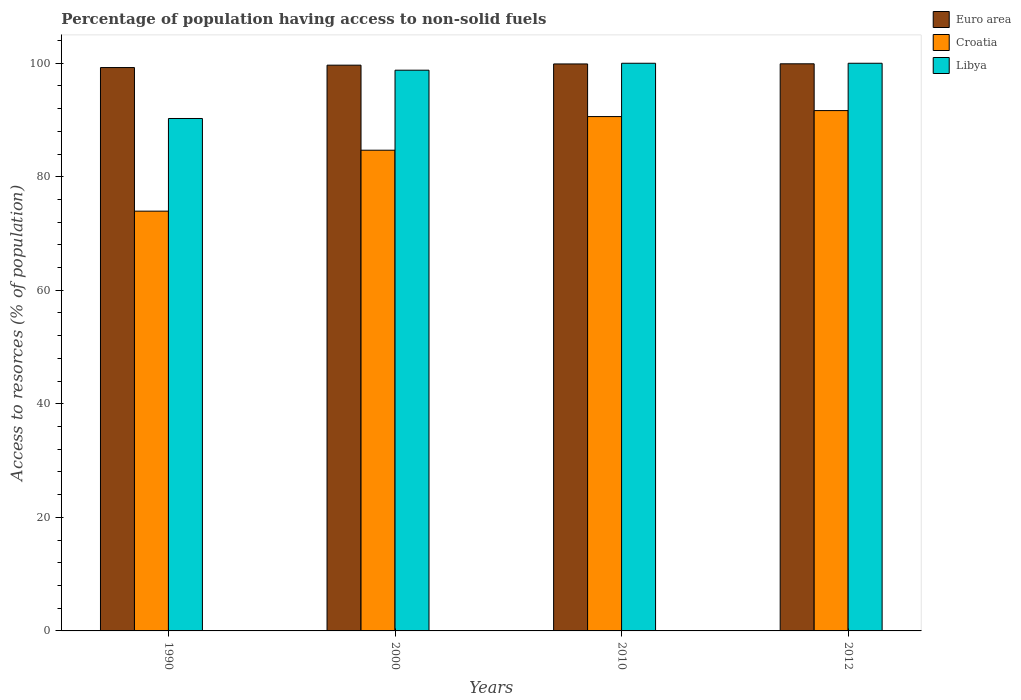How many different coloured bars are there?
Offer a terse response. 3. In how many cases, is the number of bars for a given year not equal to the number of legend labels?
Keep it short and to the point. 0. What is the percentage of population having access to non-solid fuels in Croatia in 2010?
Give a very brief answer. 90.6. Across all years, what is the maximum percentage of population having access to non-solid fuels in Libya?
Ensure brevity in your answer.  99.99. Across all years, what is the minimum percentage of population having access to non-solid fuels in Croatia?
Offer a very short reply. 73.94. In which year was the percentage of population having access to non-solid fuels in Libya maximum?
Ensure brevity in your answer.  2010. In which year was the percentage of population having access to non-solid fuels in Croatia minimum?
Keep it short and to the point. 1990. What is the total percentage of population having access to non-solid fuels in Libya in the graph?
Keep it short and to the point. 389.01. What is the difference between the percentage of population having access to non-solid fuels in Euro area in 2010 and that in 2012?
Make the answer very short. -0.02. What is the difference between the percentage of population having access to non-solid fuels in Croatia in 2000 and the percentage of population having access to non-solid fuels in Libya in 1990?
Ensure brevity in your answer.  -5.59. What is the average percentage of population having access to non-solid fuels in Libya per year?
Keep it short and to the point. 97.25. In the year 1990, what is the difference between the percentage of population having access to non-solid fuels in Libya and percentage of population having access to non-solid fuels in Euro area?
Give a very brief answer. -8.97. In how many years, is the percentage of population having access to non-solid fuels in Croatia greater than 88 %?
Give a very brief answer. 2. Is the percentage of population having access to non-solid fuels in Croatia in 1990 less than that in 2010?
Your answer should be compact. Yes. What is the difference between the highest and the second highest percentage of population having access to non-solid fuels in Croatia?
Your answer should be compact. 1.05. What is the difference between the highest and the lowest percentage of population having access to non-solid fuels in Libya?
Offer a very short reply. 9.73. In how many years, is the percentage of population having access to non-solid fuels in Libya greater than the average percentage of population having access to non-solid fuels in Libya taken over all years?
Ensure brevity in your answer.  3. Is the sum of the percentage of population having access to non-solid fuels in Euro area in 2000 and 2012 greater than the maximum percentage of population having access to non-solid fuels in Libya across all years?
Provide a succinct answer. Yes. What does the 3rd bar from the left in 1990 represents?
Offer a terse response. Libya. What does the 2nd bar from the right in 2000 represents?
Offer a terse response. Croatia. Is it the case that in every year, the sum of the percentage of population having access to non-solid fuels in Libya and percentage of population having access to non-solid fuels in Euro area is greater than the percentage of population having access to non-solid fuels in Croatia?
Provide a succinct answer. Yes. Are all the bars in the graph horizontal?
Your answer should be very brief. No. What is the difference between two consecutive major ticks on the Y-axis?
Offer a very short reply. 20. Are the values on the major ticks of Y-axis written in scientific E-notation?
Provide a short and direct response. No. Does the graph contain any zero values?
Provide a short and direct response. No. Where does the legend appear in the graph?
Offer a terse response. Top right. What is the title of the graph?
Keep it short and to the point. Percentage of population having access to non-solid fuels. Does "Marshall Islands" appear as one of the legend labels in the graph?
Your response must be concise. No. What is the label or title of the Y-axis?
Offer a very short reply. Access to resorces (% of population). What is the Access to resorces (% of population) in Euro area in 1990?
Make the answer very short. 99.23. What is the Access to resorces (% of population) in Croatia in 1990?
Offer a terse response. 73.94. What is the Access to resorces (% of population) in Libya in 1990?
Provide a succinct answer. 90.26. What is the Access to resorces (% of population) of Euro area in 2000?
Your answer should be very brief. 99.66. What is the Access to resorces (% of population) of Croatia in 2000?
Offer a very short reply. 84.67. What is the Access to resorces (% of population) of Libya in 2000?
Give a very brief answer. 98.77. What is the Access to resorces (% of population) of Euro area in 2010?
Give a very brief answer. 99.87. What is the Access to resorces (% of population) of Croatia in 2010?
Ensure brevity in your answer.  90.6. What is the Access to resorces (% of population) of Libya in 2010?
Give a very brief answer. 99.99. What is the Access to resorces (% of population) of Euro area in 2012?
Ensure brevity in your answer.  99.89. What is the Access to resorces (% of population) in Croatia in 2012?
Make the answer very short. 91.65. What is the Access to resorces (% of population) in Libya in 2012?
Make the answer very short. 99.99. Across all years, what is the maximum Access to resorces (% of population) in Euro area?
Provide a short and direct response. 99.89. Across all years, what is the maximum Access to resorces (% of population) in Croatia?
Keep it short and to the point. 91.65. Across all years, what is the maximum Access to resorces (% of population) in Libya?
Provide a succinct answer. 99.99. Across all years, what is the minimum Access to resorces (% of population) in Euro area?
Offer a terse response. 99.23. Across all years, what is the minimum Access to resorces (% of population) of Croatia?
Provide a short and direct response. 73.94. Across all years, what is the minimum Access to resorces (% of population) of Libya?
Your answer should be very brief. 90.26. What is the total Access to resorces (% of population) of Euro area in the graph?
Keep it short and to the point. 398.65. What is the total Access to resorces (% of population) in Croatia in the graph?
Ensure brevity in your answer.  340.87. What is the total Access to resorces (% of population) in Libya in the graph?
Offer a terse response. 389.01. What is the difference between the Access to resorces (% of population) of Euro area in 1990 and that in 2000?
Offer a terse response. -0.42. What is the difference between the Access to resorces (% of population) in Croatia in 1990 and that in 2000?
Provide a short and direct response. -10.73. What is the difference between the Access to resorces (% of population) in Libya in 1990 and that in 2000?
Give a very brief answer. -8.51. What is the difference between the Access to resorces (% of population) of Euro area in 1990 and that in 2010?
Your answer should be very brief. -0.64. What is the difference between the Access to resorces (% of population) in Croatia in 1990 and that in 2010?
Your answer should be very brief. -16.66. What is the difference between the Access to resorces (% of population) of Libya in 1990 and that in 2010?
Offer a very short reply. -9.73. What is the difference between the Access to resorces (% of population) of Euro area in 1990 and that in 2012?
Keep it short and to the point. -0.66. What is the difference between the Access to resorces (% of population) of Croatia in 1990 and that in 2012?
Provide a succinct answer. -17.71. What is the difference between the Access to resorces (% of population) of Libya in 1990 and that in 2012?
Provide a short and direct response. -9.73. What is the difference between the Access to resorces (% of population) in Euro area in 2000 and that in 2010?
Keep it short and to the point. -0.21. What is the difference between the Access to resorces (% of population) of Croatia in 2000 and that in 2010?
Make the answer very short. -5.93. What is the difference between the Access to resorces (% of population) in Libya in 2000 and that in 2010?
Give a very brief answer. -1.22. What is the difference between the Access to resorces (% of population) of Euro area in 2000 and that in 2012?
Provide a short and direct response. -0.24. What is the difference between the Access to resorces (% of population) of Croatia in 2000 and that in 2012?
Your answer should be very brief. -6.98. What is the difference between the Access to resorces (% of population) in Libya in 2000 and that in 2012?
Your response must be concise. -1.22. What is the difference between the Access to resorces (% of population) of Euro area in 2010 and that in 2012?
Your answer should be compact. -0.02. What is the difference between the Access to resorces (% of population) of Croatia in 2010 and that in 2012?
Your answer should be very brief. -1.05. What is the difference between the Access to resorces (% of population) in Libya in 2010 and that in 2012?
Your response must be concise. 0. What is the difference between the Access to resorces (% of population) in Euro area in 1990 and the Access to resorces (% of population) in Croatia in 2000?
Offer a very short reply. 14.56. What is the difference between the Access to resorces (% of population) in Euro area in 1990 and the Access to resorces (% of population) in Libya in 2000?
Your answer should be compact. 0.47. What is the difference between the Access to resorces (% of population) in Croatia in 1990 and the Access to resorces (% of population) in Libya in 2000?
Give a very brief answer. -24.83. What is the difference between the Access to resorces (% of population) in Euro area in 1990 and the Access to resorces (% of population) in Croatia in 2010?
Offer a very short reply. 8.63. What is the difference between the Access to resorces (% of population) in Euro area in 1990 and the Access to resorces (% of population) in Libya in 2010?
Your answer should be compact. -0.76. What is the difference between the Access to resorces (% of population) of Croatia in 1990 and the Access to resorces (% of population) of Libya in 2010?
Keep it short and to the point. -26.05. What is the difference between the Access to resorces (% of population) in Euro area in 1990 and the Access to resorces (% of population) in Croatia in 2012?
Provide a short and direct response. 7.58. What is the difference between the Access to resorces (% of population) of Euro area in 1990 and the Access to resorces (% of population) of Libya in 2012?
Provide a short and direct response. -0.76. What is the difference between the Access to resorces (% of population) of Croatia in 1990 and the Access to resorces (% of population) of Libya in 2012?
Your answer should be very brief. -26.05. What is the difference between the Access to resorces (% of population) in Euro area in 2000 and the Access to resorces (% of population) in Croatia in 2010?
Ensure brevity in your answer.  9.06. What is the difference between the Access to resorces (% of population) of Euro area in 2000 and the Access to resorces (% of population) of Libya in 2010?
Make the answer very short. -0.33. What is the difference between the Access to resorces (% of population) of Croatia in 2000 and the Access to resorces (% of population) of Libya in 2010?
Your answer should be very brief. -15.32. What is the difference between the Access to resorces (% of population) in Euro area in 2000 and the Access to resorces (% of population) in Croatia in 2012?
Offer a very short reply. 8. What is the difference between the Access to resorces (% of population) in Euro area in 2000 and the Access to resorces (% of population) in Libya in 2012?
Your answer should be compact. -0.33. What is the difference between the Access to resorces (% of population) of Croatia in 2000 and the Access to resorces (% of population) of Libya in 2012?
Offer a terse response. -15.32. What is the difference between the Access to resorces (% of population) in Euro area in 2010 and the Access to resorces (% of population) in Croatia in 2012?
Offer a terse response. 8.22. What is the difference between the Access to resorces (% of population) of Euro area in 2010 and the Access to resorces (% of population) of Libya in 2012?
Make the answer very short. -0.12. What is the difference between the Access to resorces (% of population) in Croatia in 2010 and the Access to resorces (% of population) in Libya in 2012?
Provide a succinct answer. -9.39. What is the average Access to resorces (% of population) of Euro area per year?
Keep it short and to the point. 99.66. What is the average Access to resorces (% of population) of Croatia per year?
Provide a succinct answer. 85.22. What is the average Access to resorces (% of population) of Libya per year?
Give a very brief answer. 97.25. In the year 1990, what is the difference between the Access to resorces (% of population) of Euro area and Access to resorces (% of population) of Croatia?
Ensure brevity in your answer.  25.29. In the year 1990, what is the difference between the Access to resorces (% of population) of Euro area and Access to resorces (% of population) of Libya?
Offer a terse response. 8.97. In the year 1990, what is the difference between the Access to resorces (% of population) in Croatia and Access to resorces (% of population) in Libya?
Keep it short and to the point. -16.32. In the year 2000, what is the difference between the Access to resorces (% of population) in Euro area and Access to resorces (% of population) in Croatia?
Offer a terse response. 14.98. In the year 2000, what is the difference between the Access to resorces (% of population) of Euro area and Access to resorces (% of population) of Libya?
Your answer should be compact. 0.89. In the year 2000, what is the difference between the Access to resorces (% of population) of Croatia and Access to resorces (% of population) of Libya?
Your answer should be very brief. -14.09. In the year 2010, what is the difference between the Access to resorces (% of population) of Euro area and Access to resorces (% of population) of Croatia?
Make the answer very short. 9.27. In the year 2010, what is the difference between the Access to resorces (% of population) in Euro area and Access to resorces (% of population) in Libya?
Give a very brief answer. -0.12. In the year 2010, what is the difference between the Access to resorces (% of population) in Croatia and Access to resorces (% of population) in Libya?
Offer a very short reply. -9.39. In the year 2012, what is the difference between the Access to resorces (% of population) of Euro area and Access to resorces (% of population) of Croatia?
Your answer should be very brief. 8.24. In the year 2012, what is the difference between the Access to resorces (% of population) in Euro area and Access to resorces (% of population) in Libya?
Offer a terse response. -0.1. In the year 2012, what is the difference between the Access to resorces (% of population) of Croatia and Access to resorces (% of population) of Libya?
Your response must be concise. -8.34. What is the ratio of the Access to resorces (% of population) in Euro area in 1990 to that in 2000?
Your answer should be very brief. 1. What is the ratio of the Access to resorces (% of population) of Croatia in 1990 to that in 2000?
Keep it short and to the point. 0.87. What is the ratio of the Access to resorces (% of population) in Libya in 1990 to that in 2000?
Provide a succinct answer. 0.91. What is the ratio of the Access to resorces (% of population) in Croatia in 1990 to that in 2010?
Keep it short and to the point. 0.82. What is the ratio of the Access to resorces (% of population) of Libya in 1990 to that in 2010?
Give a very brief answer. 0.9. What is the ratio of the Access to resorces (% of population) of Euro area in 1990 to that in 2012?
Provide a short and direct response. 0.99. What is the ratio of the Access to resorces (% of population) in Croatia in 1990 to that in 2012?
Provide a short and direct response. 0.81. What is the ratio of the Access to resorces (% of population) of Libya in 1990 to that in 2012?
Give a very brief answer. 0.9. What is the ratio of the Access to resorces (% of population) of Croatia in 2000 to that in 2010?
Offer a very short reply. 0.93. What is the ratio of the Access to resorces (% of population) in Libya in 2000 to that in 2010?
Your answer should be compact. 0.99. What is the ratio of the Access to resorces (% of population) in Croatia in 2000 to that in 2012?
Ensure brevity in your answer.  0.92. What is the ratio of the Access to resorces (% of population) in Croatia in 2010 to that in 2012?
Make the answer very short. 0.99. What is the difference between the highest and the second highest Access to resorces (% of population) of Euro area?
Provide a short and direct response. 0.02. What is the difference between the highest and the second highest Access to resorces (% of population) of Croatia?
Ensure brevity in your answer.  1.05. What is the difference between the highest and the second highest Access to resorces (% of population) of Libya?
Ensure brevity in your answer.  0. What is the difference between the highest and the lowest Access to resorces (% of population) of Euro area?
Keep it short and to the point. 0.66. What is the difference between the highest and the lowest Access to resorces (% of population) in Croatia?
Your response must be concise. 17.71. What is the difference between the highest and the lowest Access to resorces (% of population) in Libya?
Give a very brief answer. 9.73. 